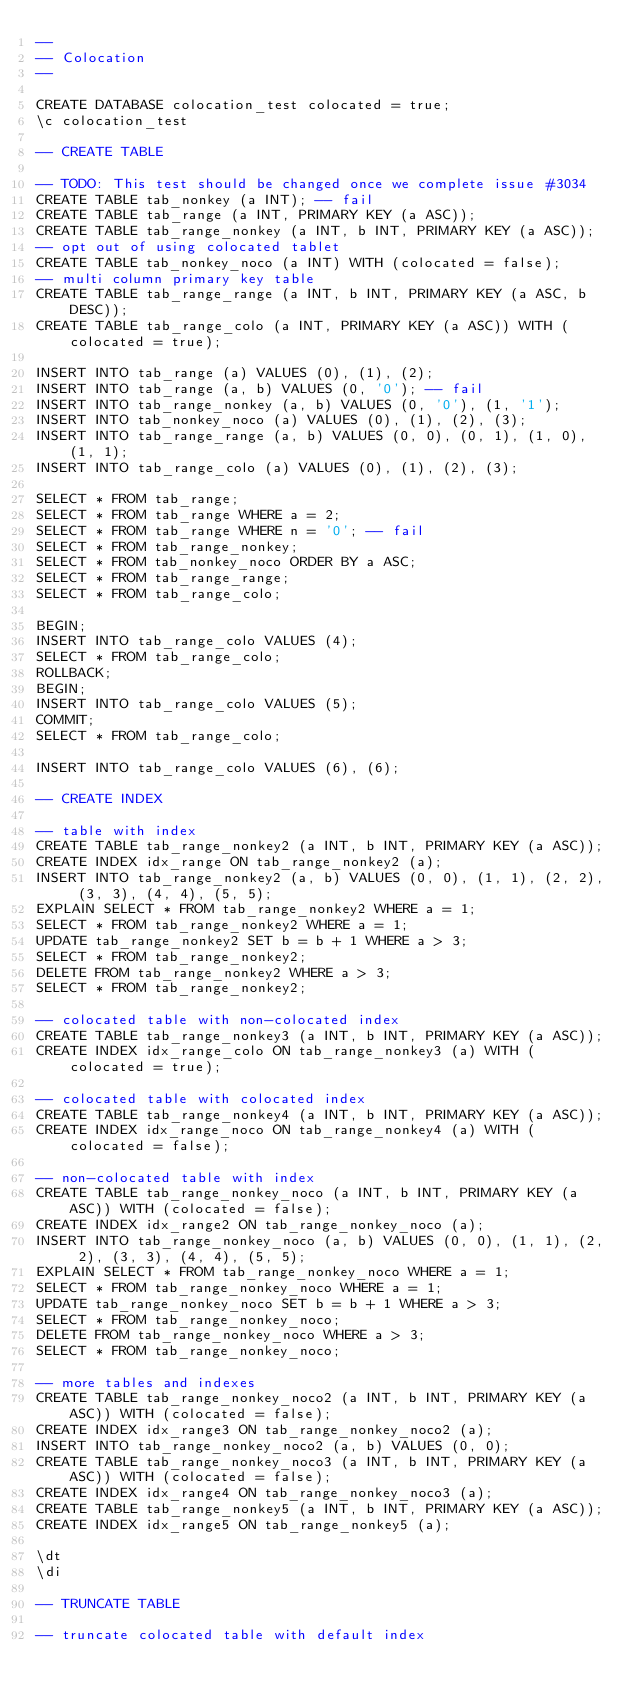<code> <loc_0><loc_0><loc_500><loc_500><_SQL_>--
-- Colocation
--

CREATE DATABASE colocation_test colocated = true;
\c colocation_test

-- CREATE TABLE

-- TODO: This test should be changed once we complete issue #3034
CREATE TABLE tab_nonkey (a INT); -- fail
CREATE TABLE tab_range (a INT, PRIMARY KEY (a ASC));
CREATE TABLE tab_range_nonkey (a INT, b INT, PRIMARY KEY (a ASC));
-- opt out of using colocated tablet
CREATE TABLE tab_nonkey_noco (a INT) WITH (colocated = false);
-- multi column primary key table
CREATE TABLE tab_range_range (a INT, b INT, PRIMARY KEY (a ASC, b DESC));
CREATE TABLE tab_range_colo (a INT, PRIMARY KEY (a ASC)) WITH (colocated = true);

INSERT INTO tab_range (a) VALUES (0), (1), (2);
INSERT INTO tab_range (a, b) VALUES (0, '0'); -- fail
INSERT INTO tab_range_nonkey (a, b) VALUES (0, '0'), (1, '1');
INSERT INTO tab_nonkey_noco (a) VALUES (0), (1), (2), (3);
INSERT INTO tab_range_range (a, b) VALUES (0, 0), (0, 1), (1, 0), (1, 1);
INSERT INTO tab_range_colo (a) VALUES (0), (1), (2), (3);

SELECT * FROM tab_range;
SELECT * FROM tab_range WHERE a = 2;
SELECT * FROM tab_range WHERE n = '0'; -- fail
SELECT * FROM tab_range_nonkey;
SELECT * FROM tab_nonkey_noco ORDER BY a ASC;
SELECT * FROM tab_range_range;
SELECT * FROM tab_range_colo;

BEGIN;
INSERT INTO tab_range_colo VALUES (4);
SELECT * FROM tab_range_colo;
ROLLBACK;
BEGIN;
INSERT INTO tab_range_colo VALUES (5);
COMMIT;
SELECT * FROM tab_range_colo;

INSERT INTO tab_range_colo VALUES (6), (6);

-- CREATE INDEX

-- table with index
CREATE TABLE tab_range_nonkey2 (a INT, b INT, PRIMARY KEY (a ASC));
CREATE INDEX idx_range ON tab_range_nonkey2 (a);
INSERT INTO tab_range_nonkey2 (a, b) VALUES (0, 0), (1, 1), (2, 2), (3, 3), (4, 4), (5, 5);
EXPLAIN SELECT * FROM tab_range_nonkey2 WHERE a = 1;
SELECT * FROM tab_range_nonkey2 WHERE a = 1;
UPDATE tab_range_nonkey2 SET b = b + 1 WHERE a > 3;
SELECT * FROM tab_range_nonkey2;
DELETE FROM tab_range_nonkey2 WHERE a > 3;
SELECT * FROM tab_range_nonkey2;

-- colocated table with non-colocated index
CREATE TABLE tab_range_nonkey3 (a INT, b INT, PRIMARY KEY (a ASC));
CREATE INDEX idx_range_colo ON tab_range_nonkey3 (a) WITH (colocated = true);

-- colocated table with colocated index
CREATE TABLE tab_range_nonkey4 (a INT, b INT, PRIMARY KEY (a ASC));
CREATE INDEX idx_range_noco ON tab_range_nonkey4 (a) WITH (colocated = false);

-- non-colocated table with index
CREATE TABLE tab_range_nonkey_noco (a INT, b INT, PRIMARY KEY (a ASC)) WITH (colocated = false);
CREATE INDEX idx_range2 ON tab_range_nonkey_noco (a);
INSERT INTO tab_range_nonkey_noco (a, b) VALUES (0, 0), (1, 1), (2, 2), (3, 3), (4, 4), (5, 5);
EXPLAIN SELECT * FROM tab_range_nonkey_noco WHERE a = 1;
SELECT * FROM tab_range_nonkey_noco WHERE a = 1;
UPDATE tab_range_nonkey_noco SET b = b + 1 WHERE a > 3;
SELECT * FROM tab_range_nonkey_noco;
DELETE FROM tab_range_nonkey_noco WHERE a > 3;
SELECT * FROM tab_range_nonkey_noco;

-- more tables and indexes
CREATE TABLE tab_range_nonkey_noco2 (a INT, b INT, PRIMARY KEY (a ASC)) WITH (colocated = false);
CREATE INDEX idx_range3 ON tab_range_nonkey_noco2 (a);
INSERT INTO tab_range_nonkey_noco2 (a, b) VALUES (0, 0);
CREATE TABLE tab_range_nonkey_noco3 (a INT, b INT, PRIMARY KEY (a ASC)) WITH (colocated = false);
CREATE INDEX idx_range4 ON tab_range_nonkey_noco3 (a);
CREATE TABLE tab_range_nonkey5 (a INT, b INT, PRIMARY KEY (a ASC));
CREATE INDEX idx_range5 ON tab_range_nonkey5 (a);

\dt
\di

-- TRUNCATE TABLE

-- truncate colocated table with default index</code> 